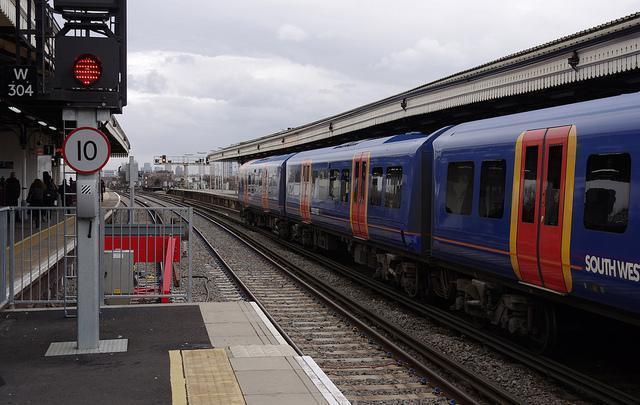What airline is advertised on the train?
Answer the question by selecting the correct answer among the 4 following choices.
Options: Southwest, united, delta, american. Southwest. 